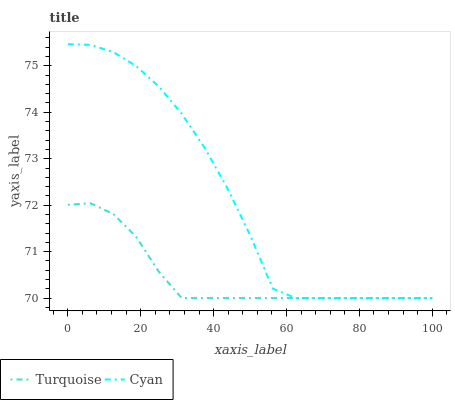Does Turquoise have the minimum area under the curve?
Answer yes or no. Yes. Does Cyan have the maximum area under the curve?
Answer yes or no. Yes. Does Turquoise have the maximum area under the curve?
Answer yes or no. No. Is Turquoise the smoothest?
Answer yes or no. Yes. Is Cyan the roughest?
Answer yes or no. Yes. Is Turquoise the roughest?
Answer yes or no. No. Does Cyan have the lowest value?
Answer yes or no. Yes. Does Cyan have the highest value?
Answer yes or no. Yes. Does Turquoise have the highest value?
Answer yes or no. No. Does Cyan intersect Turquoise?
Answer yes or no. Yes. Is Cyan less than Turquoise?
Answer yes or no. No. Is Cyan greater than Turquoise?
Answer yes or no. No. 